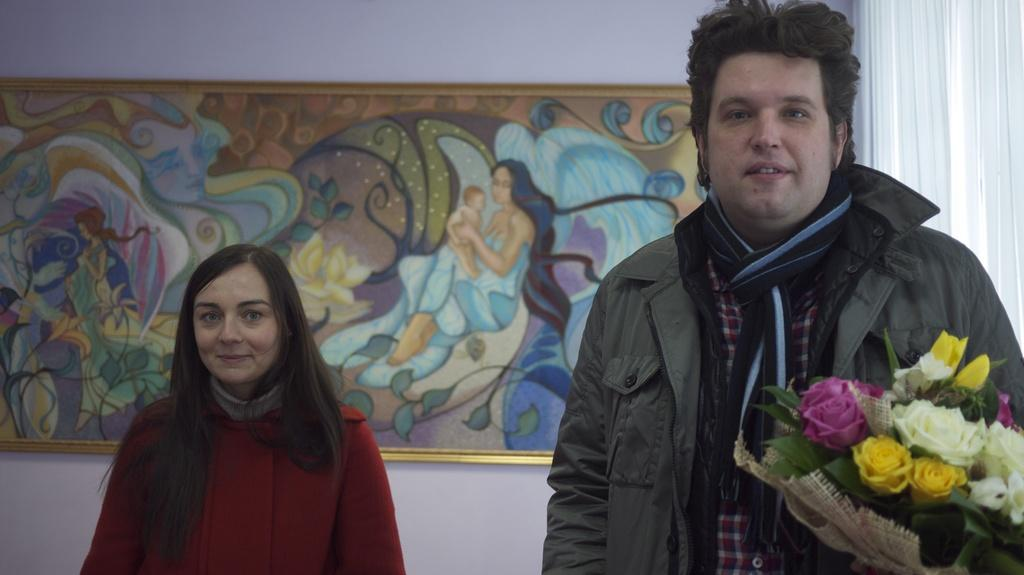How many people are present in the image? There are two persons in the image. What can be seen besides the two persons? There is a bouquet in the image. What is on the wall in the image? There is a photo frame on the wall in the image. What type of window treatment is present in the image? There is a curtain in the image. What type of glue is being used by the boy in the image? There is no boy present in the image, and no glue is visible. What type of tank is visible in the image? There is no tank present in the image. 